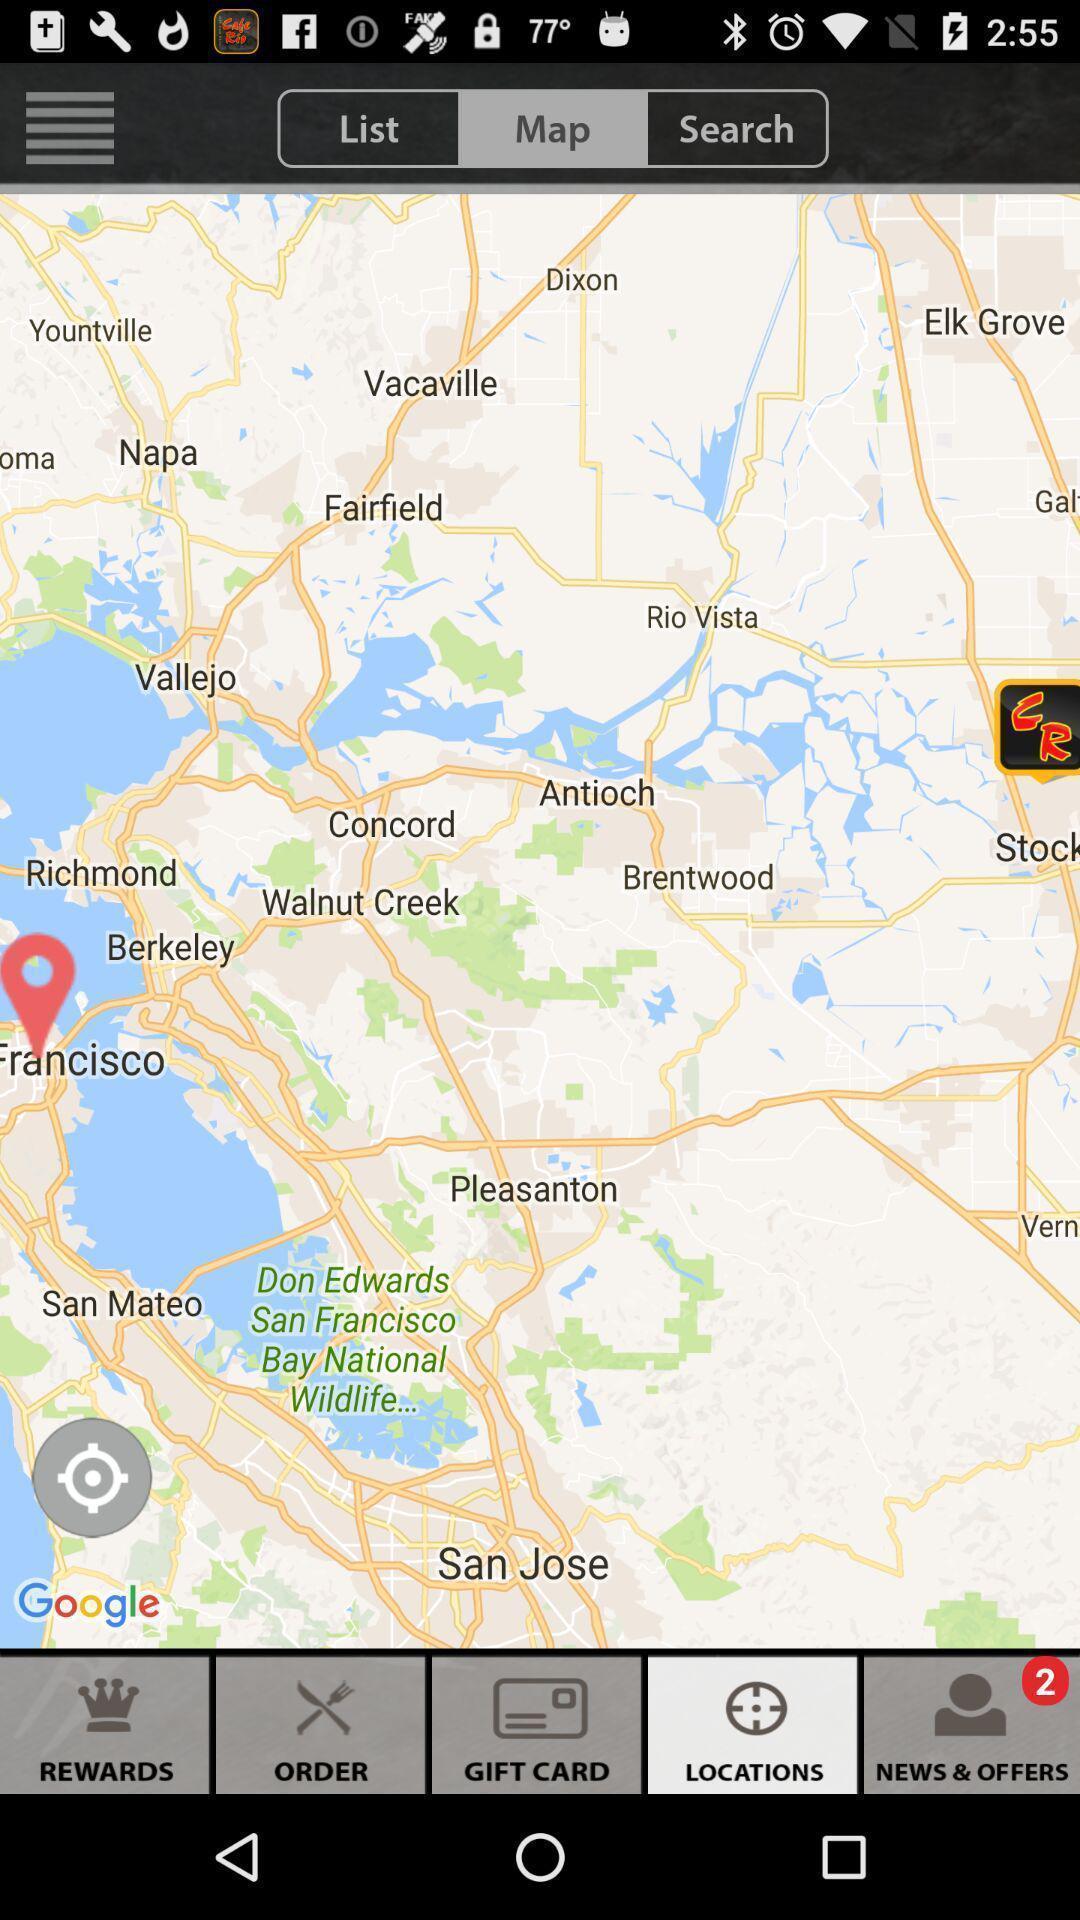Explain what's happening in this screen capture. Page showing various places on map. 